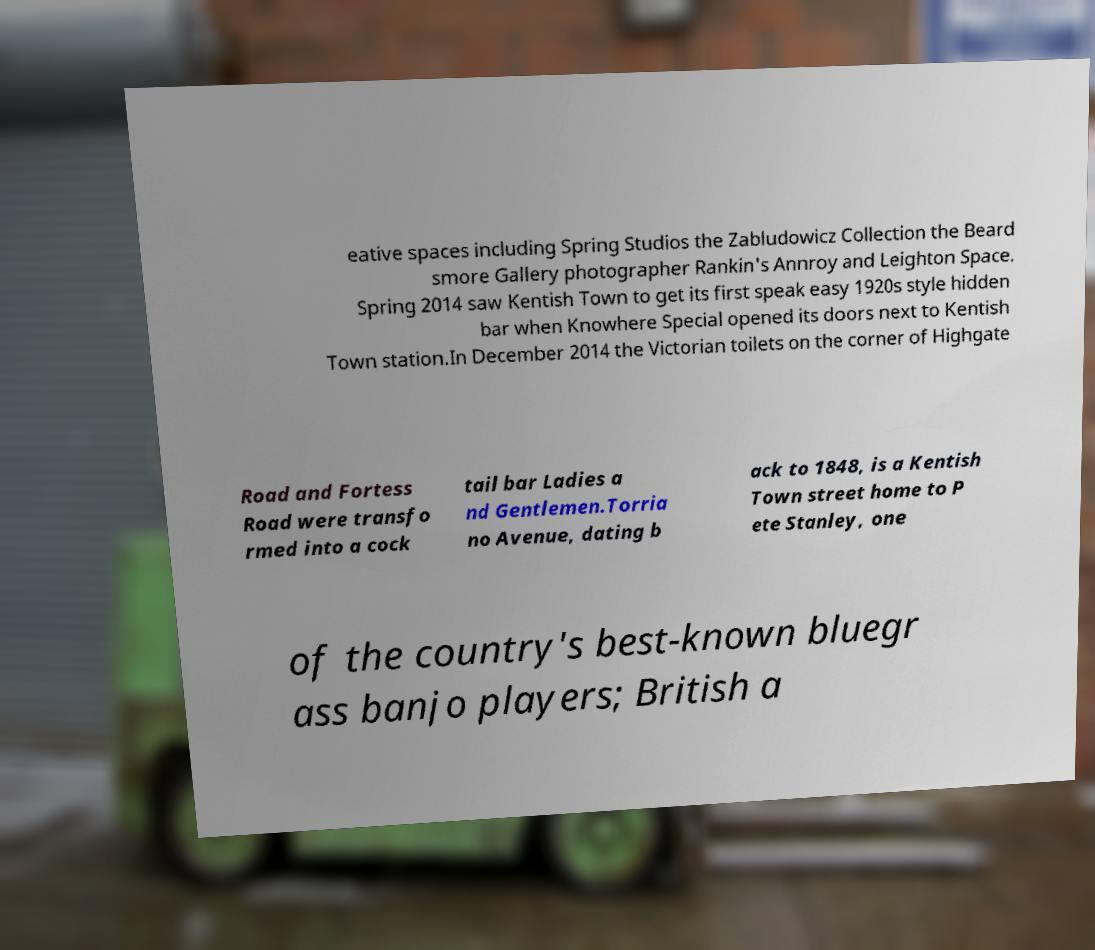I need the written content from this picture converted into text. Can you do that? eative spaces including Spring Studios the Zabludowicz Collection the Beard smore Gallery photographer Rankin's Annroy and Leighton Space. Spring 2014 saw Kentish Town to get its first speak easy 1920s style hidden bar when Knowhere Special opened its doors next to Kentish Town station.In December 2014 the Victorian toilets on the corner of Highgate Road and Fortess Road were transfo rmed into a cock tail bar Ladies a nd Gentlemen.Torria no Avenue, dating b ack to 1848, is a Kentish Town street home to P ete Stanley, one of the country's best-known bluegr ass banjo players; British a 